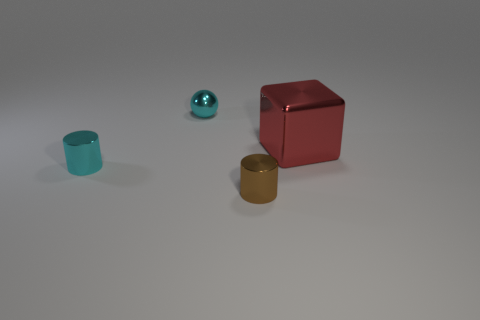Add 1 small metal cylinders. How many objects exist? 5 Subtract all spheres. How many objects are left? 3 Subtract 1 blocks. How many blocks are left? 0 Subtract all brown cylinders. How many cylinders are left? 1 Add 4 green matte blocks. How many green matte blocks exist? 4 Subtract 0 yellow blocks. How many objects are left? 4 Subtract all red balls. Subtract all red blocks. How many balls are left? 1 Subtract all cyan blocks. How many gray cylinders are left? 0 Subtract all tiny brown metallic things. Subtract all tiny blue rubber balls. How many objects are left? 3 Add 3 small brown cylinders. How many small brown cylinders are left? 4 